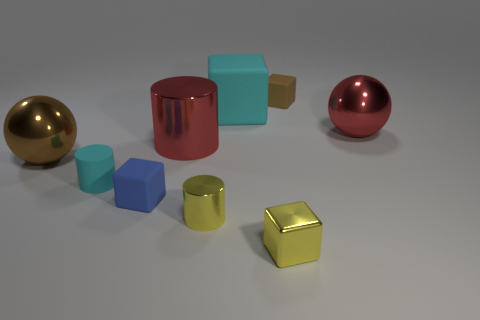Subtract 1 cubes. How many cubes are left? 3 Subtract all green cubes. Subtract all brown cylinders. How many cubes are left? 4 Subtract all cylinders. How many objects are left? 6 Add 2 big cyan matte objects. How many big cyan matte objects exist? 3 Subtract 0 green cylinders. How many objects are left? 9 Subtract all large brown metal objects. Subtract all cyan cubes. How many objects are left? 7 Add 6 tiny metallic cylinders. How many tiny metallic cylinders are left? 7 